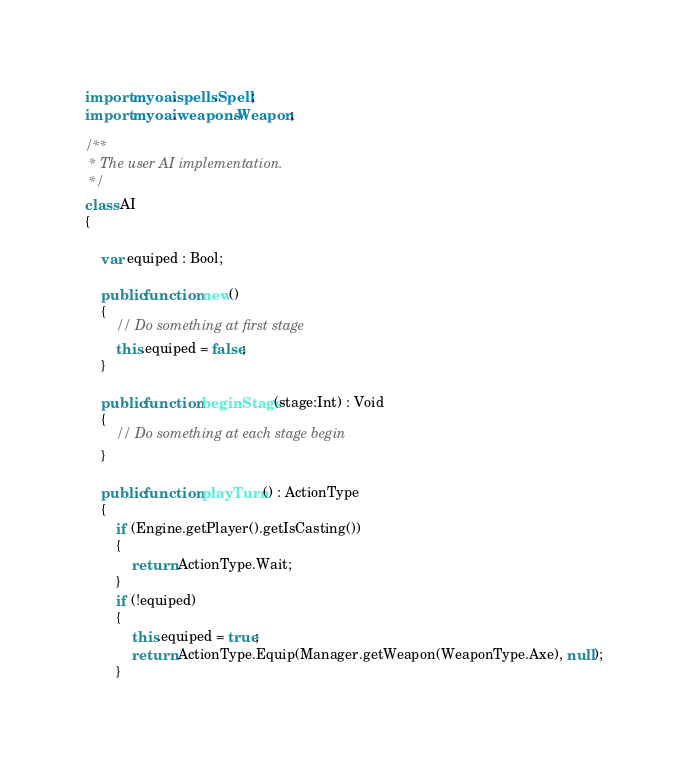<code> <loc_0><loc_0><loc_500><loc_500><_Haxe_>import myoai.spells.Spell;
import myoai.weapons.Weapon;

/**
 * The user AI implementation.
 */
class AI 
{
	
	var equiped : Bool;
	
	public function new()
	{
		// Do something at first stage
		this.equiped = false;
	}
	
	public function beginStage(stage:Int) : Void
	{
		// Do something at each stage begin
	}
	
	public function playTurn() : ActionType
	{
		if (Engine.getPlayer().getIsCasting())
		{
			return ActionType.Wait;
		}
		if (!equiped)
		{
			this.equiped = true;
			return ActionType.Equip(Manager.getWeapon(WeaponType.Axe), null);
		}</code> 